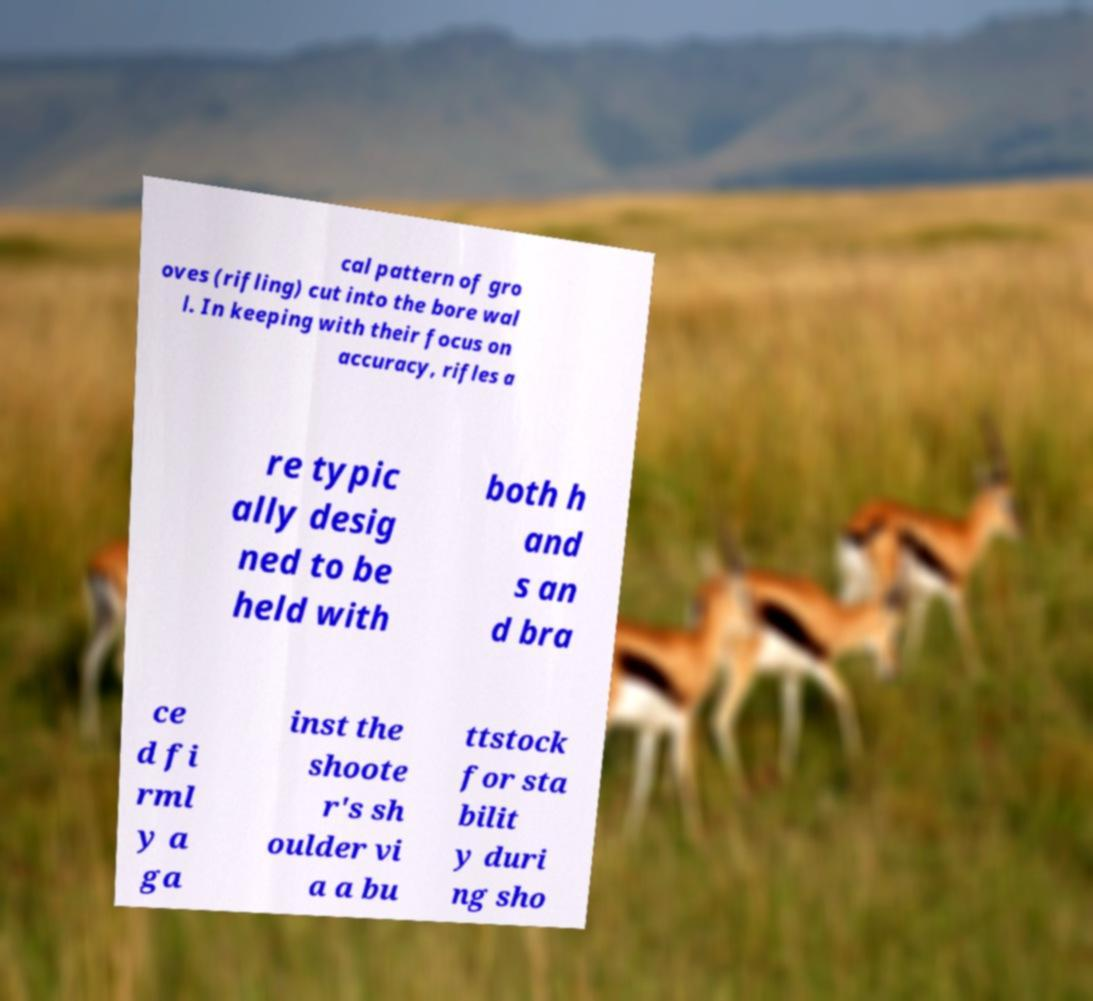I need the written content from this picture converted into text. Can you do that? cal pattern of gro oves (rifling) cut into the bore wal l. In keeping with their focus on accuracy, rifles a re typic ally desig ned to be held with both h and s an d bra ce d fi rml y a ga inst the shoote r's sh oulder vi a a bu ttstock for sta bilit y duri ng sho 